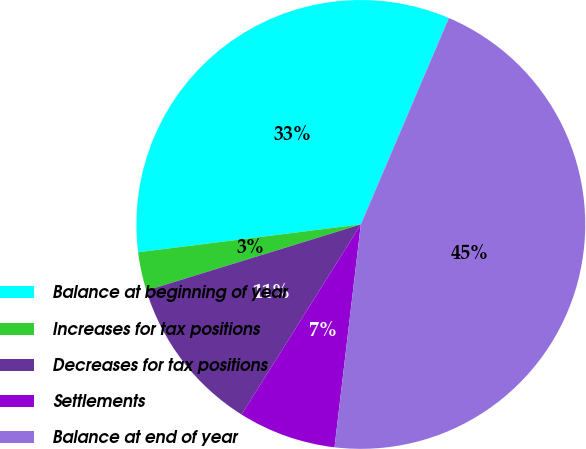<chart> <loc_0><loc_0><loc_500><loc_500><pie_chart><fcel>Balance at beginning of year<fcel>Increases for tax positions<fcel>Decreases for tax positions<fcel>Settlements<fcel>Balance at end of year<nl><fcel>33.4%<fcel>2.78%<fcel>11.32%<fcel>7.05%<fcel>45.45%<nl></chart> 